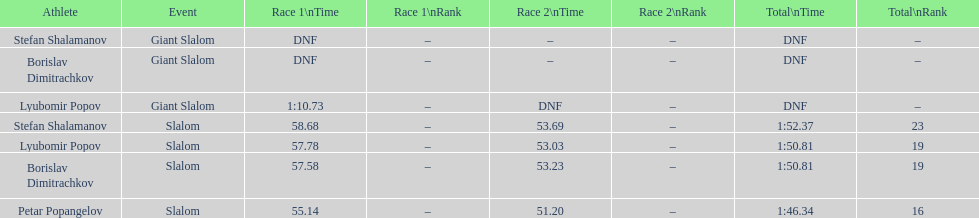Which athlete finished the first race but did not finish the second race? Lyubomir Popov. 